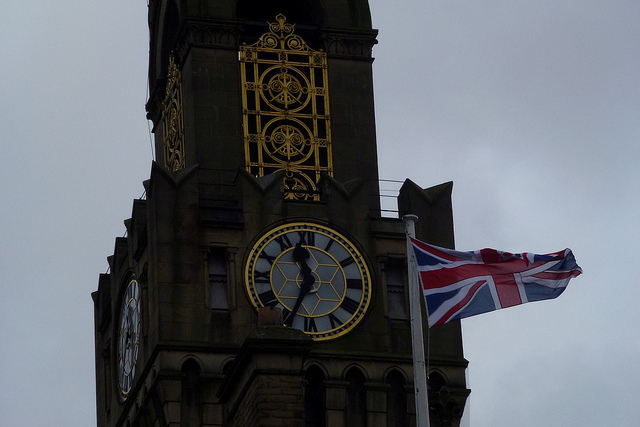<image>What color is the statue? I am not sure about the color of the statue. It may be brown, gold or grayish. What color is the statue? I don't know the color of the statue. 